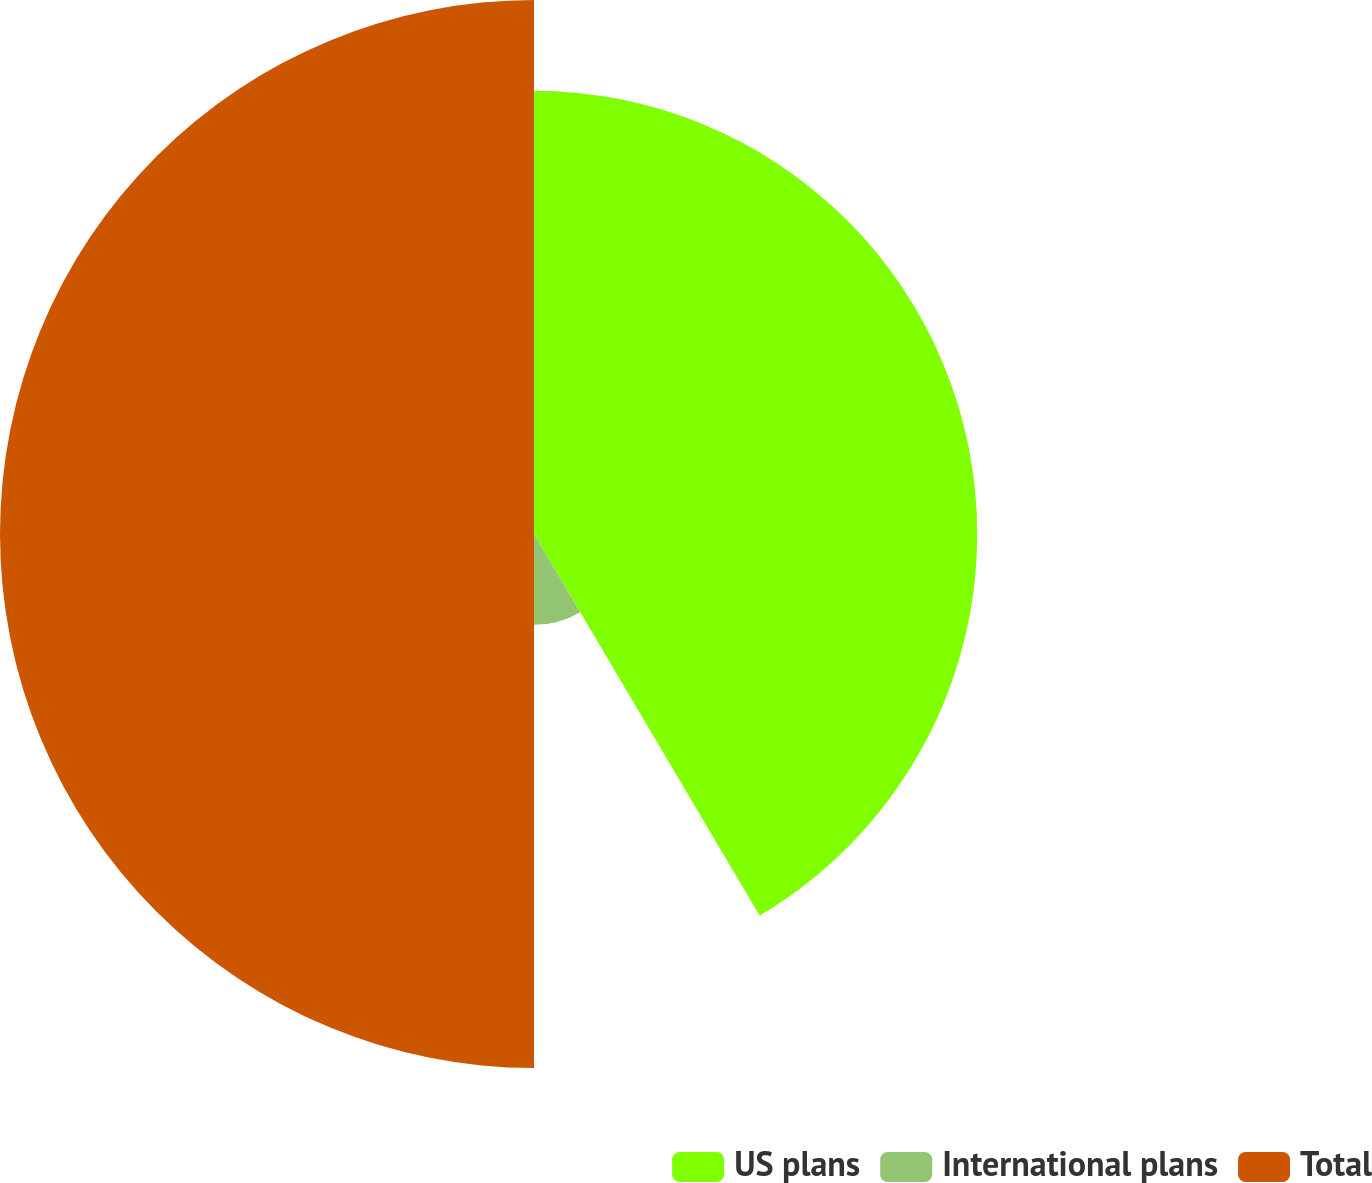Convert chart. <chart><loc_0><loc_0><loc_500><loc_500><pie_chart><fcel>US plans<fcel>International plans<fcel>Total<nl><fcel>41.5%<fcel>8.5%<fcel>50.0%<nl></chart> 